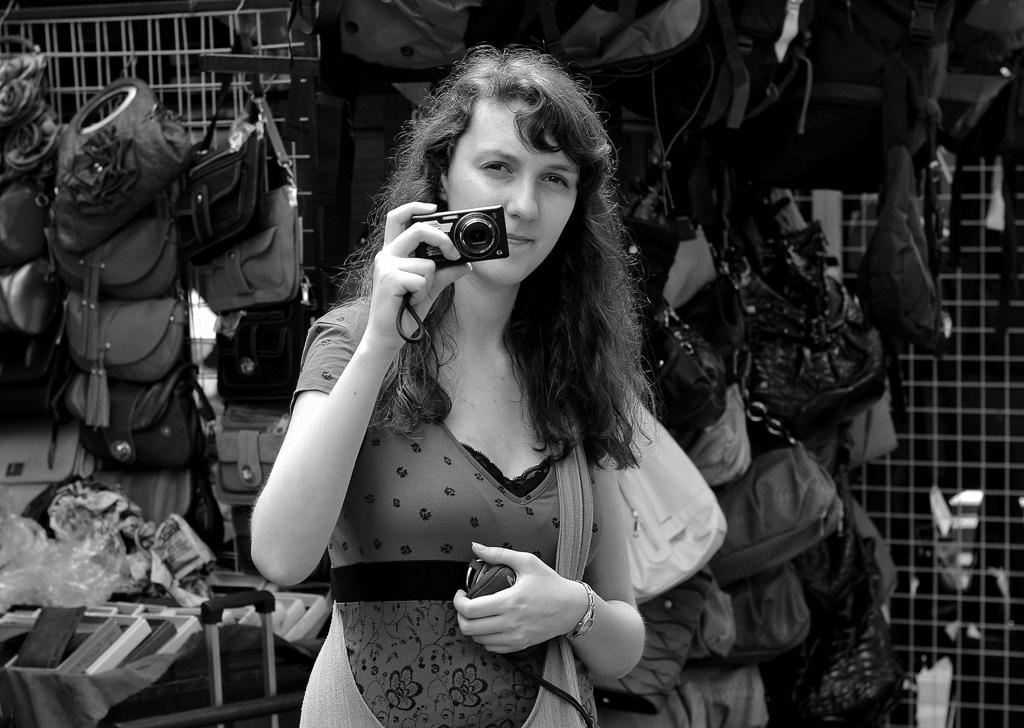Who is the main subject in the image? There is a lady in the image. What is the lady holding in her right hand? The lady is holding a camera in her right hand. What can be seen in the background of the image? There are handbags in the background of the image. How are the handbags positioned in the image? The handbags are attached to a fence. What type of spark can be seen coming from the lady's camera in the image? There is no spark coming from the lady's camera in the image. What is the lady eating for breakfast in the image? There is no breakfast or food visible in the image. 